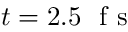Convert formula to latex. <formula><loc_0><loc_0><loc_500><loc_500>t = 2 . 5 f s</formula> 